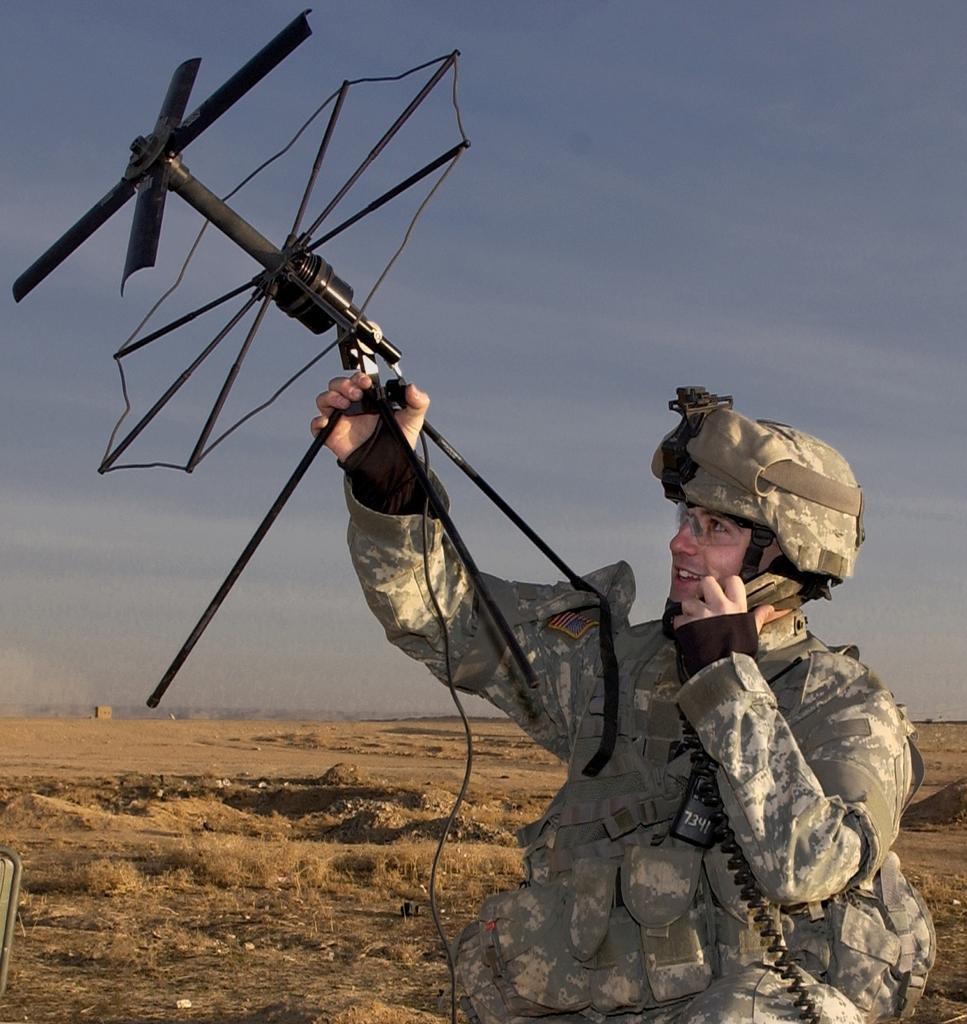Could you give a brief overview of what you see in this image? In this picture we can see a person, he is holding an object and in the background we can see grass on the ground and we can see sky. 